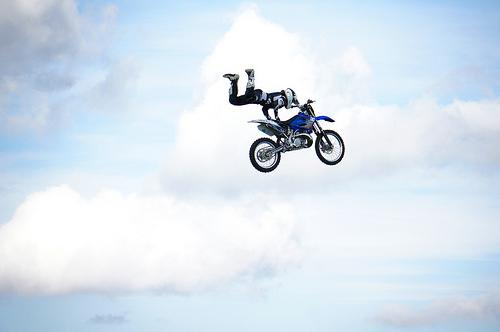Question: who is in the air?
Choices:
A. Airplane passenger.
B. Kids in the hot air balloon.
C. Motorbike driver.
D. Teenager doing skateboard trick.
Answer with the letter. Answer: C Question: what is in the background?
Choices:
A. House.
B. Church.
C. Clock.
D. Clouds.
Answer with the letter. Answer: D Question: why are the rider's feet in the air?
Choices:
A. He fell.
B. Doing a trick.
C. Bike turned over.
D. Stunt.
Answer with the letter. Answer: D Question: how long was the rider in the air?
Choices:
A. No indication.
B. Cant be determined.
C. Less than a minute.
D. Thirty seconds.
Answer with the letter. Answer: A 